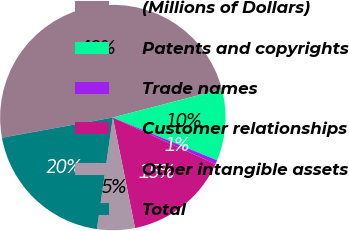<chart> <loc_0><loc_0><loc_500><loc_500><pie_chart><fcel>(Millions of Dollars)<fcel>Patents and copyrights<fcel>Trade names<fcel>Customer relationships<fcel>Other intangible assets<fcel>Total<nl><fcel>48.82%<fcel>10.24%<fcel>0.59%<fcel>15.06%<fcel>5.41%<fcel>19.88%<nl></chart> 